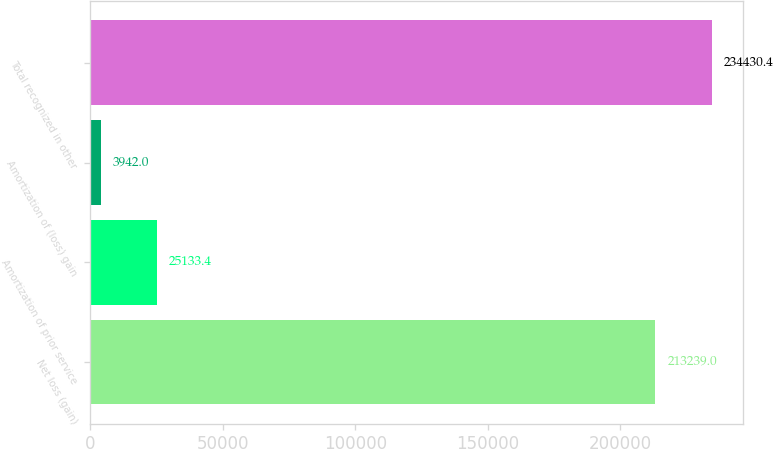Convert chart. <chart><loc_0><loc_0><loc_500><loc_500><bar_chart><fcel>Net loss (gain)<fcel>Amortization of prior service<fcel>Amortization of (loss) gain<fcel>Total recognized in other<nl><fcel>213239<fcel>25133.4<fcel>3942<fcel>234430<nl></chart> 